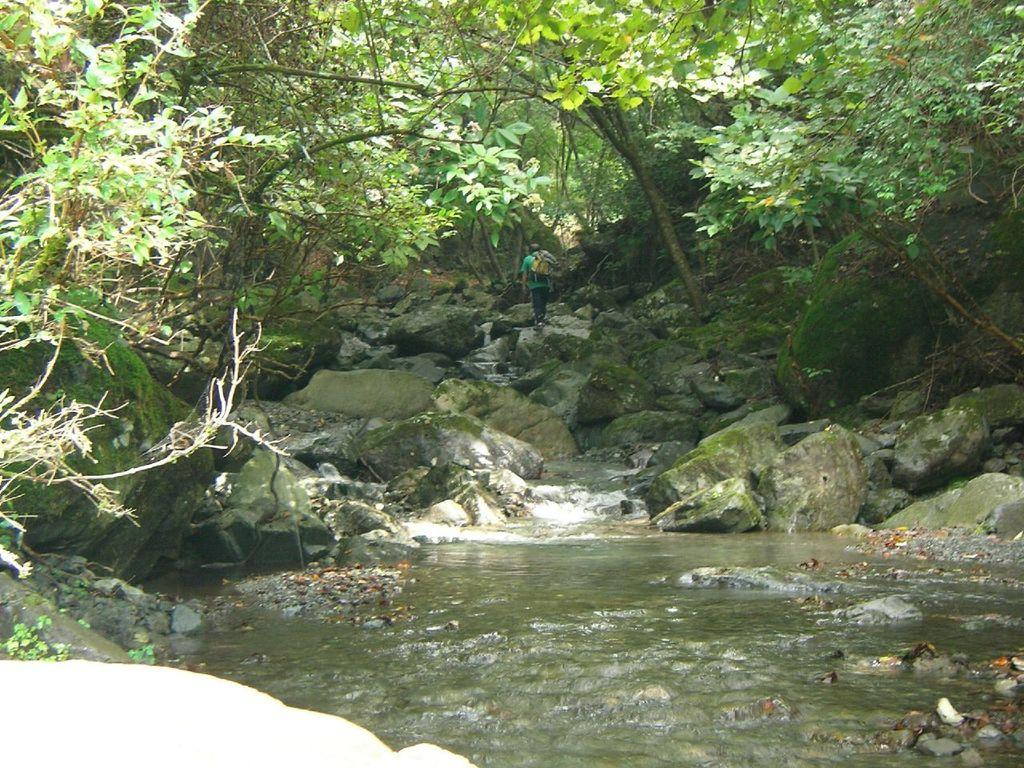What type of natural environment can be seen in the background of the image? There are trees visible in the background of the image. What is the person in the background doing? The person is walking in the background. What color is the person's t-shirt? The person is wearing a green t-shirt. What type of geological features can be seen in the image? There are rocks visible in the image. What type of water feature is present in the image? There is water visible in the image. What type of small plants can be seen in the image? Small plants are present in the image. What flavor of bone can be seen in the image? There is no bone present in the image, and therefore no flavor can be determined. How does the person wash their hands in the image? There is no indication of hand washing in the image; the person is simply walking. 